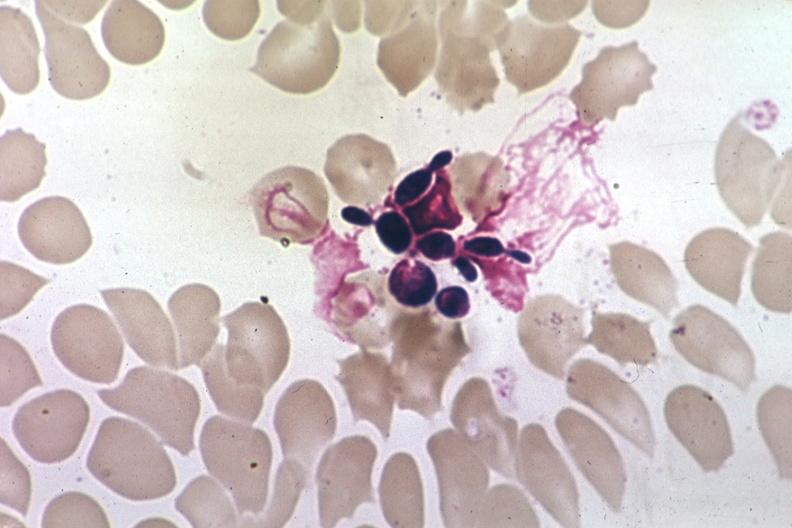what is present?
Answer the question using a single word or phrase. Candida in peripheral blood 